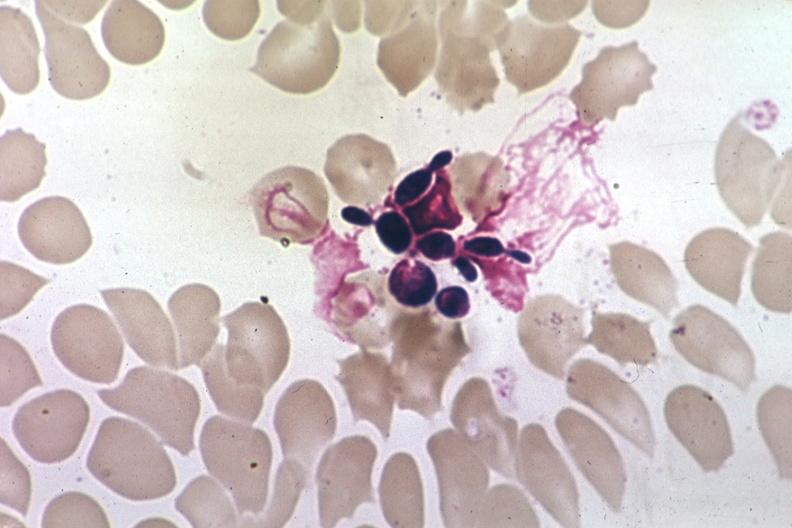what is present?
Answer the question using a single word or phrase. Candida in peripheral blood 